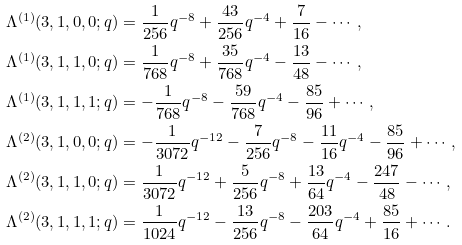<formula> <loc_0><loc_0><loc_500><loc_500>\Lambda ^ { ( 1 ) } ( 3 , 1 , 0 , 0 ; q ) & = \frac { 1 } { 2 5 6 } q ^ { - 8 } + \frac { 4 3 } { 2 5 6 } q ^ { - 4 } + \frac { 7 } { 1 6 } - \cdots , \\ \Lambda ^ { ( 1 ) } ( 3 , 1 , 1 , 0 ; q ) & = \frac { 1 } { 7 6 8 } q ^ { - 8 } + \frac { 3 5 } { 7 6 8 } q ^ { - 4 } - \frac { 1 3 } { 4 8 } - \cdots , \\ \Lambda ^ { ( 1 ) } ( 3 , 1 , 1 , 1 ; q ) & = - \frac { 1 } { 7 6 8 } q ^ { - 8 } - \frac { 5 9 } { 7 6 8 } q ^ { - 4 } - \frac { 8 5 } { 9 6 } + \cdots , \\ \Lambda ^ { ( 2 ) } ( 3 , 1 , 0 , 0 ; q ) & = - \frac { 1 } { 3 0 7 2 } q ^ { - 1 2 } - \frac { 7 } { 2 5 6 } q ^ { - 8 } - \frac { 1 1 } { 1 6 } q ^ { - 4 } - \frac { 8 5 } { 9 6 } + \cdots , \\ \Lambda ^ { ( 2 ) } ( 3 , 1 , 1 , 0 ; q ) & = \frac { 1 } { 3 0 7 2 } q ^ { - 1 2 } + \frac { 5 } { 2 5 6 } q ^ { - 8 } + \frac { 1 3 } { 6 4 } q ^ { - 4 } - \frac { 2 4 7 } { 4 8 } - \cdots , \\ \Lambda ^ { ( 2 ) } ( 3 , 1 , 1 , 1 ; q ) & = \frac { 1 } { 1 0 2 4 } q ^ { - 1 2 } - \frac { 1 3 } { 2 5 6 } q ^ { - 8 } - \frac { 2 0 3 } { 6 4 } q ^ { - 4 } + \frac { 8 5 } { 1 6 } + \cdots .</formula> 